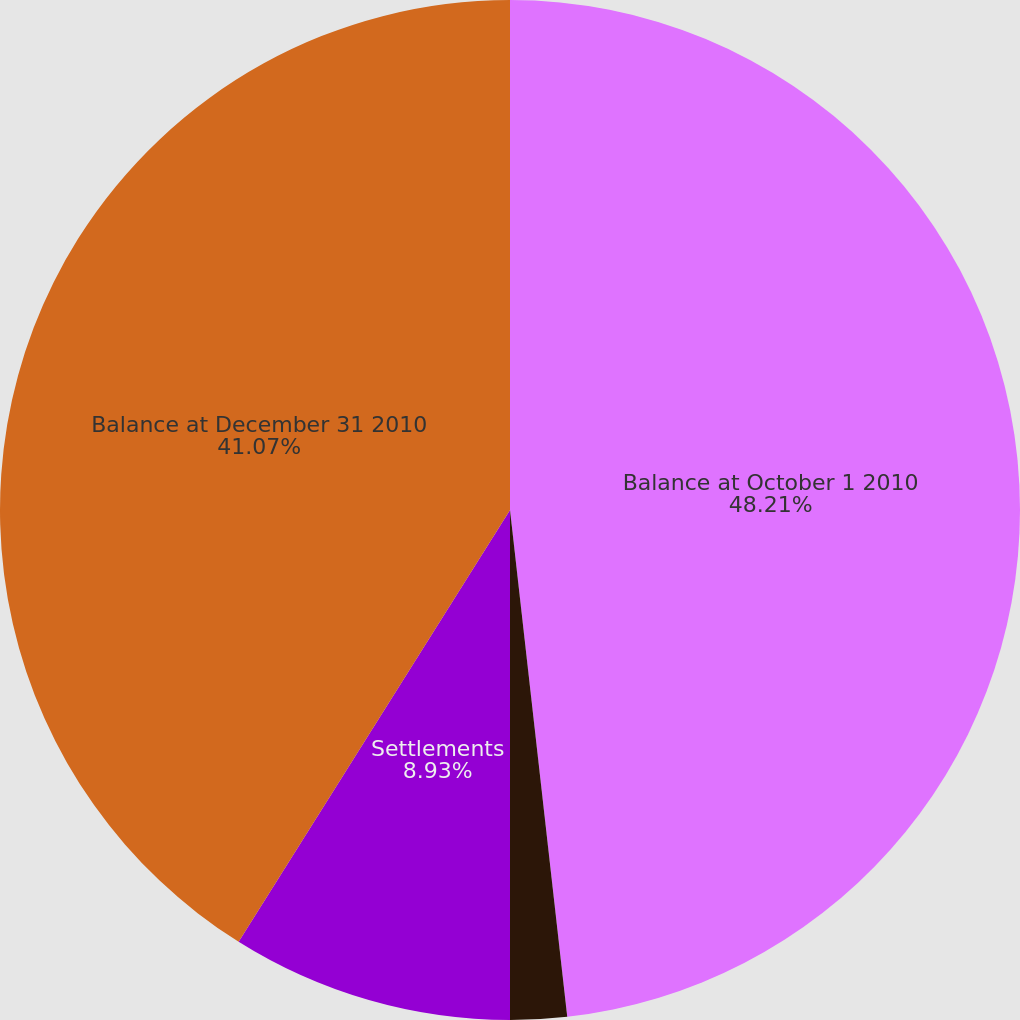Convert chart to OTSL. <chart><loc_0><loc_0><loc_500><loc_500><pie_chart><fcel>Balance at October 1 2010<fcel>Included in earnings<fcel>Settlements<fcel>Balance at December 31 2010<nl><fcel>48.21%<fcel>1.79%<fcel>8.93%<fcel>41.07%<nl></chart> 